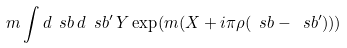<formula> <loc_0><loc_0><loc_500><loc_500>m \int d \ s { b } \, d \ s { b } ^ { \prime } \, Y \exp ( m ( X + i \pi \rho ( \ s { b } - \ s { b } ^ { \prime } ) ) )</formula> 